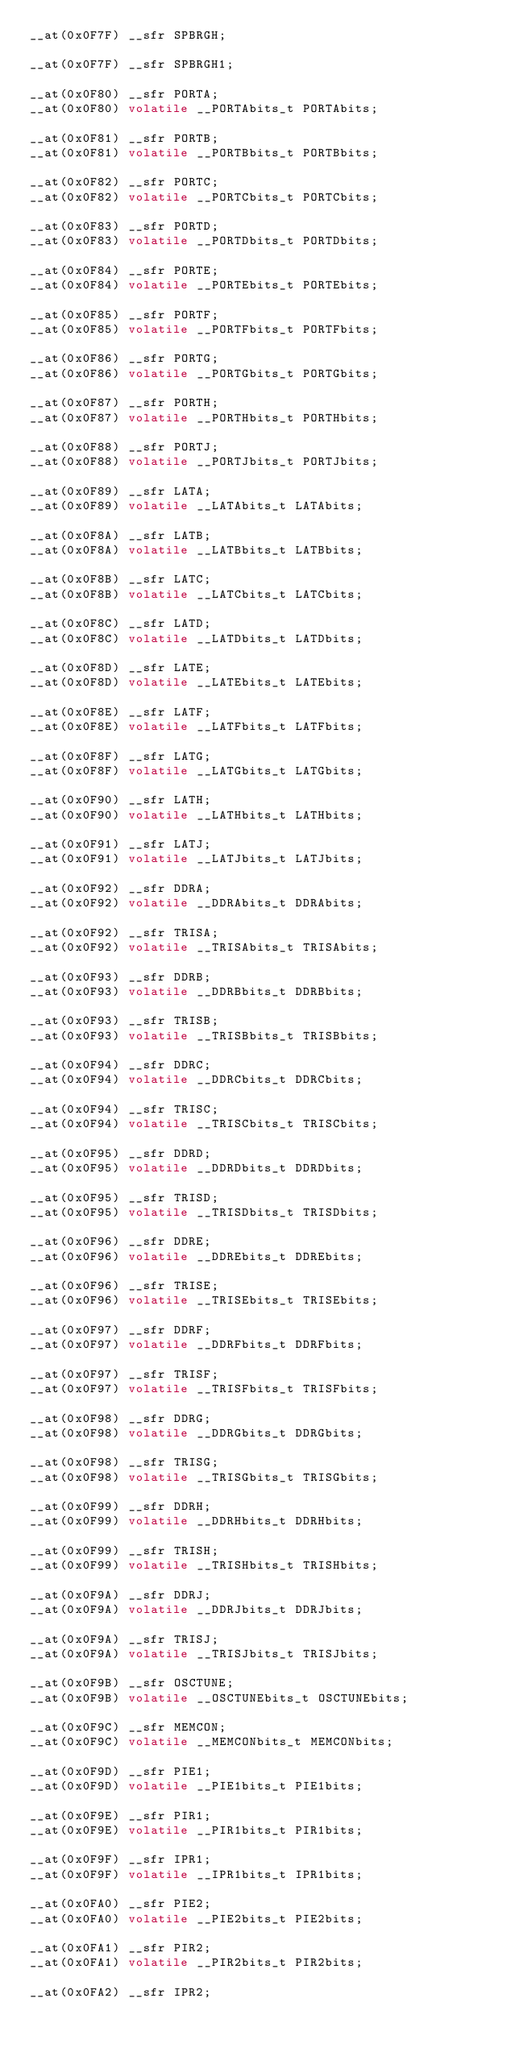<code> <loc_0><loc_0><loc_500><loc_500><_C_>__at(0x0F7F) __sfr SPBRGH;

__at(0x0F7F) __sfr SPBRGH1;

__at(0x0F80) __sfr PORTA;
__at(0x0F80) volatile __PORTAbits_t PORTAbits;

__at(0x0F81) __sfr PORTB;
__at(0x0F81) volatile __PORTBbits_t PORTBbits;

__at(0x0F82) __sfr PORTC;
__at(0x0F82) volatile __PORTCbits_t PORTCbits;

__at(0x0F83) __sfr PORTD;
__at(0x0F83) volatile __PORTDbits_t PORTDbits;

__at(0x0F84) __sfr PORTE;
__at(0x0F84) volatile __PORTEbits_t PORTEbits;

__at(0x0F85) __sfr PORTF;
__at(0x0F85) volatile __PORTFbits_t PORTFbits;

__at(0x0F86) __sfr PORTG;
__at(0x0F86) volatile __PORTGbits_t PORTGbits;

__at(0x0F87) __sfr PORTH;
__at(0x0F87) volatile __PORTHbits_t PORTHbits;

__at(0x0F88) __sfr PORTJ;
__at(0x0F88) volatile __PORTJbits_t PORTJbits;

__at(0x0F89) __sfr LATA;
__at(0x0F89) volatile __LATAbits_t LATAbits;

__at(0x0F8A) __sfr LATB;
__at(0x0F8A) volatile __LATBbits_t LATBbits;

__at(0x0F8B) __sfr LATC;
__at(0x0F8B) volatile __LATCbits_t LATCbits;

__at(0x0F8C) __sfr LATD;
__at(0x0F8C) volatile __LATDbits_t LATDbits;

__at(0x0F8D) __sfr LATE;
__at(0x0F8D) volatile __LATEbits_t LATEbits;

__at(0x0F8E) __sfr LATF;
__at(0x0F8E) volatile __LATFbits_t LATFbits;

__at(0x0F8F) __sfr LATG;
__at(0x0F8F) volatile __LATGbits_t LATGbits;

__at(0x0F90) __sfr LATH;
__at(0x0F90) volatile __LATHbits_t LATHbits;

__at(0x0F91) __sfr LATJ;
__at(0x0F91) volatile __LATJbits_t LATJbits;

__at(0x0F92) __sfr DDRA;
__at(0x0F92) volatile __DDRAbits_t DDRAbits;

__at(0x0F92) __sfr TRISA;
__at(0x0F92) volatile __TRISAbits_t TRISAbits;

__at(0x0F93) __sfr DDRB;
__at(0x0F93) volatile __DDRBbits_t DDRBbits;

__at(0x0F93) __sfr TRISB;
__at(0x0F93) volatile __TRISBbits_t TRISBbits;

__at(0x0F94) __sfr DDRC;
__at(0x0F94) volatile __DDRCbits_t DDRCbits;

__at(0x0F94) __sfr TRISC;
__at(0x0F94) volatile __TRISCbits_t TRISCbits;

__at(0x0F95) __sfr DDRD;
__at(0x0F95) volatile __DDRDbits_t DDRDbits;

__at(0x0F95) __sfr TRISD;
__at(0x0F95) volatile __TRISDbits_t TRISDbits;

__at(0x0F96) __sfr DDRE;
__at(0x0F96) volatile __DDREbits_t DDREbits;

__at(0x0F96) __sfr TRISE;
__at(0x0F96) volatile __TRISEbits_t TRISEbits;

__at(0x0F97) __sfr DDRF;
__at(0x0F97) volatile __DDRFbits_t DDRFbits;

__at(0x0F97) __sfr TRISF;
__at(0x0F97) volatile __TRISFbits_t TRISFbits;

__at(0x0F98) __sfr DDRG;
__at(0x0F98) volatile __DDRGbits_t DDRGbits;

__at(0x0F98) __sfr TRISG;
__at(0x0F98) volatile __TRISGbits_t TRISGbits;

__at(0x0F99) __sfr DDRH;
__at(0x0F99) volatile __DDRHbits_t DDRHbits;

__at(0x0F99) __sfr TRISH;
__at(0x0F99) volatile __TRISHbits_t TRISHbits;

__at(0x0F9A) __sfr DDRJ;
__at(0x0F9A) volatile __DDRJbits_t DDRJbits;

__at(0x0F9A) __sfr TRISJ;
__at(0x0F9A) volatile __TRISJbits_t TRISJbits;

__at(0x0F9B) __sfr OSCTUNE;
__at(0x0F9B) volatile __OSCTUNEbits_t OSCTUNEbits;

__at(0x0F9C) __sfr MEMCON;
__at(0x0F9C) volatile __MEMCONbits_t MEMCONbits;

__at(0x0F9D) __sfr PIE1;
__at(0x0F9D) volatile __PIE1bits_t PIE1bits;

__at(0x0F9E) __sfr PIR1;
__at(0x0F9E) volatile __PIR1bits_t PIR1bits;

__at(0x0F9F) __sfr IPR1;
__at(0x0F9F) volatile __IPR1bits_t IPR1bits;

__at(0x0FA0) __sfr PIE2;
__at(0x0FA0) volatile __PIE2bits_t PIE2bits;

__at(0x0FA1) __sfr PIR2;
__at(0x0FA1) volatile __PIR2bits_t PIR2bits;

__at(0x0FA2) __sfr IPR2;</code> 